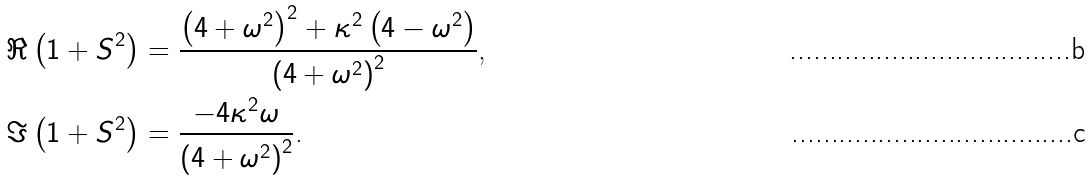Convert formula to latex. <formula><loc_0><loc_0><loc_500><loc_500>\Re \left ( 1 + S ^ { 2 } \right ) & = \frac { \left ( 4 + \omega ^ { 2 } \right ) ^ { 2 } + \kappa ^ { 2 } \left ( 4 - \omega ^ { 2 } \right ) } { \left ( 4 + \omega ^ { 2 } \right ) ^ { 2 } } \text {,} \\ \Im \left ( 1 + S ^ { 2 } \right ) & = \frac { - 4 \kappa ^ { 2 } \omega } { \left ( 4 + \omega ^ { 2 } \right ) ^ { 2 } } \text {.}</formula> 